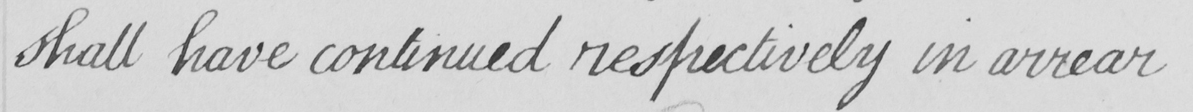Please provide the text content of this handwritten line. shall have continued respectively in arrear 